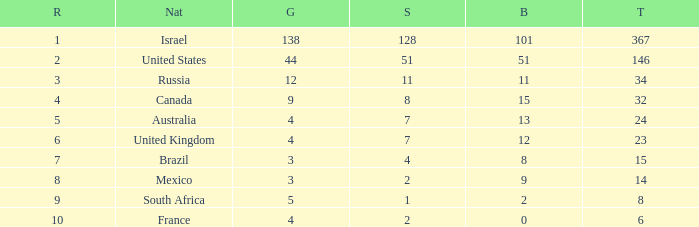Parse the table in full. {'header': ['R', 'Nat', 'G', 'S', 'B', 'T'], 'rows': [['1', 'Israel', '138', '128', '101', '367'], ['2', 'United States', '44', '51', '51', '146'], ['3', 'Russia', '12', '11', '11', '34'], ['4', 'Canada', '9', '8', '15', '32'], ['5', 'Australia', '4', '7', '13', '24'], ['6', 'United Kingdom', '4', '7', '12', '23'], ['7', 'Brazil', '3', '4', '8', '15'], ['8', 'Mexico', '3', '2', '9', '14'], ['9', 'South Africa', '5', '1', '2', '8'], ['10', 'France', '4', '2', '0', '6']]} What is the gold medal count for the country with a total greater than 32 and more than 128 silvers? None. 